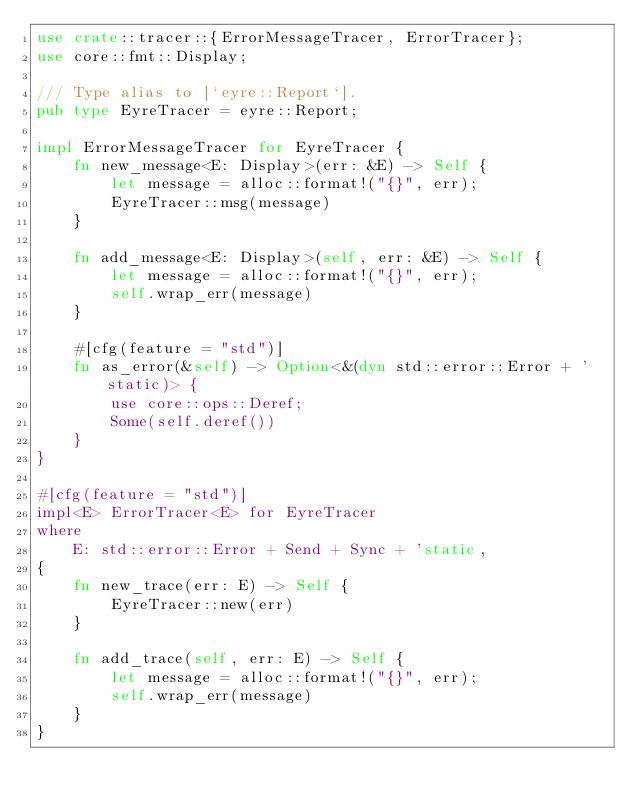<code> <loc_0><loc_0><loc_500><loc_500><_Rust_>use crate::tracer::{ErrorMessageTracer, ErrorTracer};
use core::fmt::Display;

/// Type alias to [`eyre::Report`].
pub type EyreTracer = eyre::Report;

impl ErrorMessageTracer for EyreTracer {
    fn new_message<E: Display>(err: &E) -> Self {
        let message = alloc::format!("{}", err);
        EyreTracer::msg(message)
    }

    fn add_message<E: Display>(self, err: &E) -> Self {
        let message = alloc::format!("{}", err);
        self.wrap_err(message)
    }

    #[cfg(feature = "std")]
    fn as_error(&self) -> Option<&(dyn std::error::Error + 'static)> {
        use core::ops::Deref;
        Some(self.deref())
    }
}

#[cfg(feature = "std")]
impl<E> ErrorTracer<E> for EyreTracer
where
    E: std::error::Error + Send + Sync + 'static,
{
    fn new_trace(err: E) -> Self {
        EyreTracer::new(err)
    }

    fn add_trace(self, err: E) -> Self {
        let message = alloc::format!("{}", err);
        self.wrap_err(message)
    }
}
</code> 